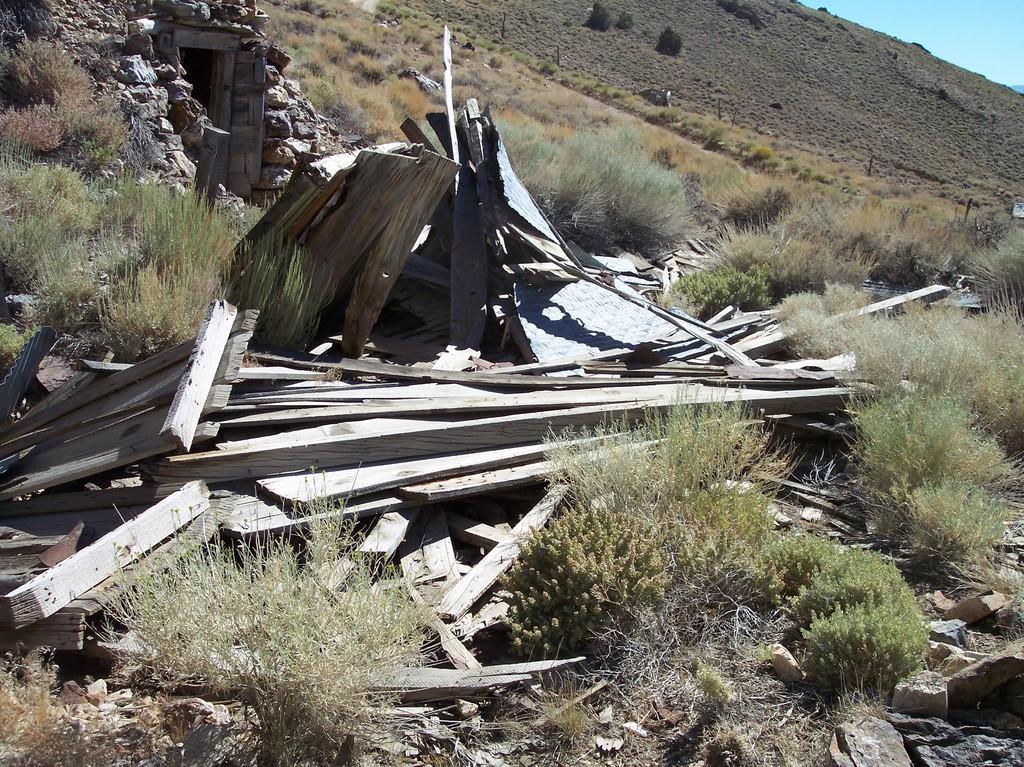Can you describe this image briefly? This is an outside view. Here I can see some wood materials, plants, rocks on the ground. On the top right, I can see the sky. 